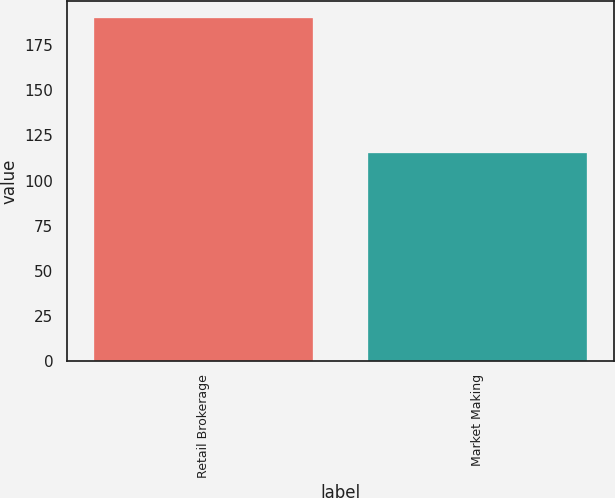Convert chart to OTSL. <chart><loc_0><loc_0><loc_500><loc_500><bar_chart><fcel>Retail Brokerage<fcel>Market Making<nl><fcel>190<fcel>115<nl></chart> 